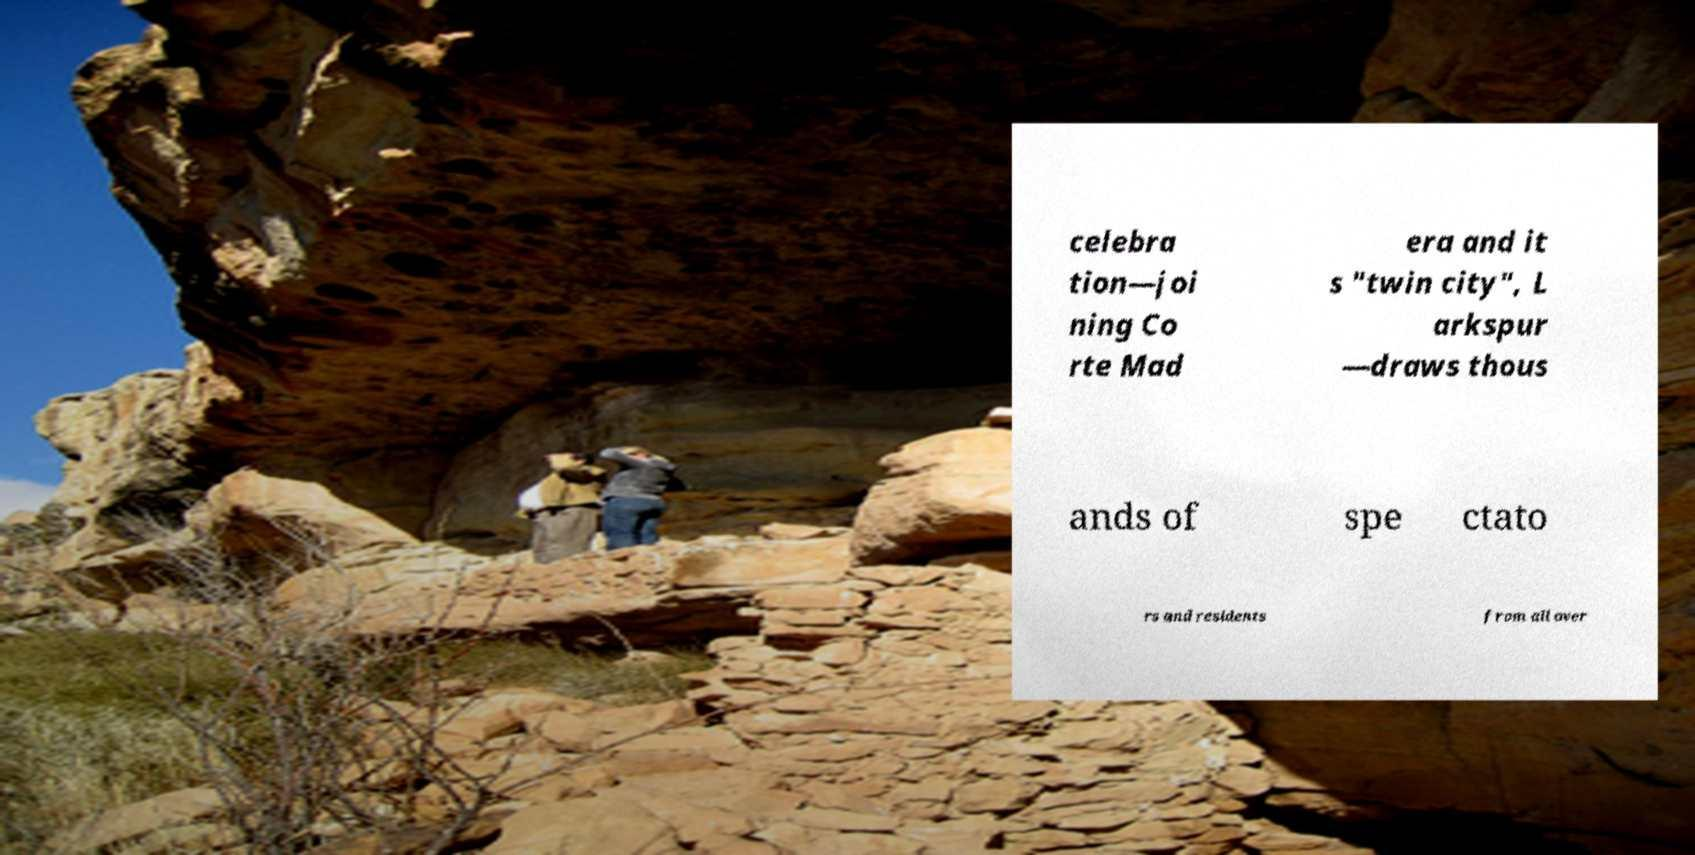For documentation purposes, I need the text within this image transcribed. Could you provide that? celebra tion—joi ning Co rte Mad era and it s "twin city", L arkspur —draws thous ands of spe ctato rs and residents from all over 